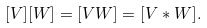<formula> <loc_0><loc_0><loc_500><loc_500>[ V ] [ W ] = [ V W ] = [ V * W ] .</formula> 